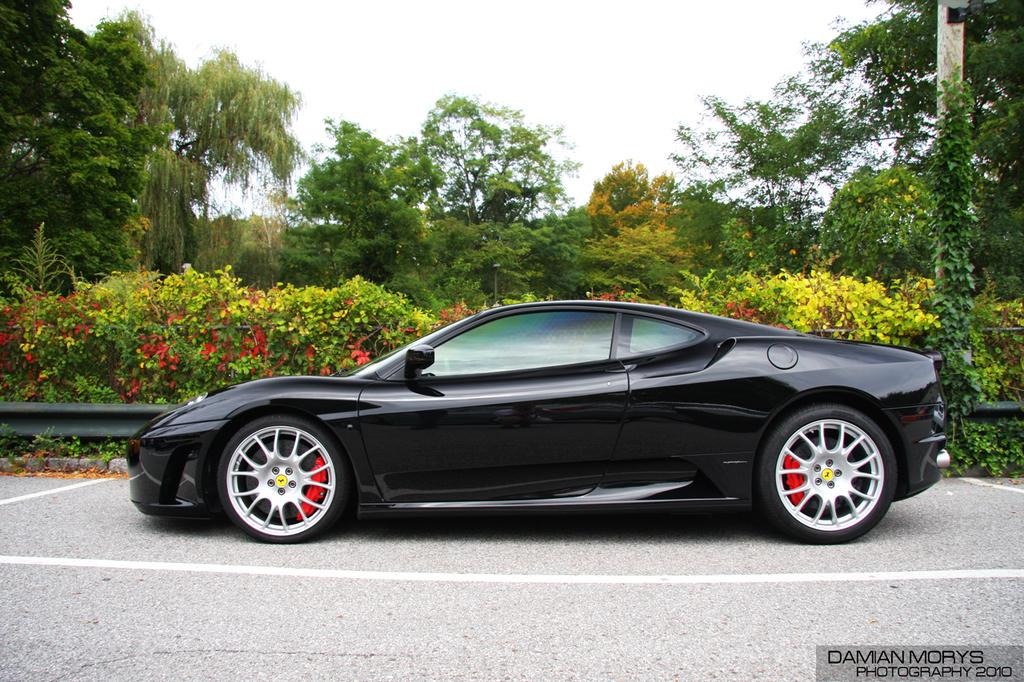What is the main subject of the image? The main subject of the image is a car on the road. Where is the car located in the image? The car is at the bottom of the image. What can be seen in the background of the image? There are trees in the background of the image. What is visible at the top of the image? The sky is visible at the top of the image. What type of cub is sitting on the car in the image? There is no cub present in the image; it features a car on the road with trees and the sky in the background. How many cherries are on the car in the image? There are no cherries present on the car in the image. 